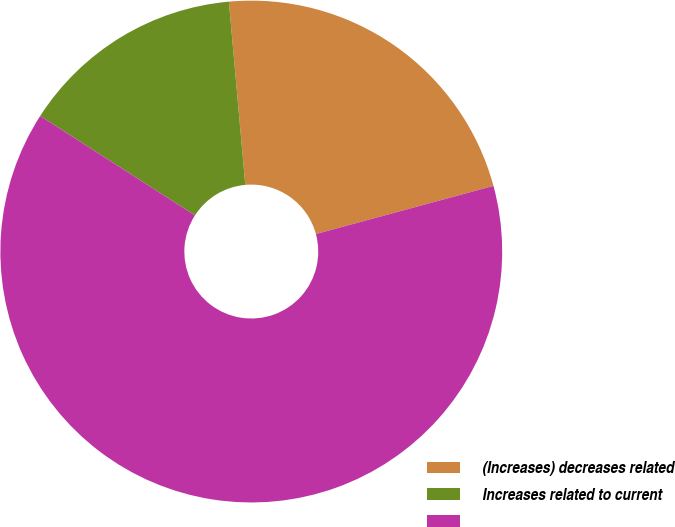<chart> <loc_0><loc_0><loc_500><loc_500><pie_chart><fcel>(Increases) decreases related<fcel>Increases related to current<fcel>Unnamed: 2<nl><fcel>22.21%<fcel>14.49%<fcel>63.3%<nl></chart> 